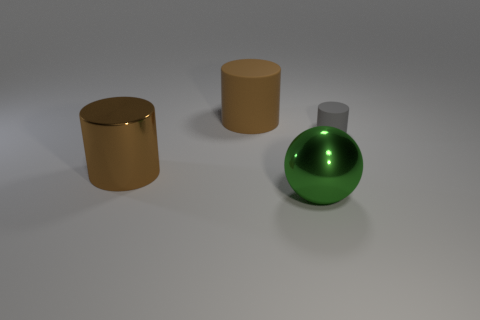There is a cylinder that is both behind the shiny cylinder and to the left of the tiny object; what color is it?
Make the answer very short. Brown. What is the size of the matte cylinder on the left side of the green object?
Give a very brief answer. Large. How many yellow blocks are made of the same material as the small object?
Keep it short and to the point. 0. What shape is the big object that is the same color as the metallic cylinder?
Provide a succinct answer. Cylinder. There is a large brown rubber object left of the tiny rubber thing; is it the same shape as the small gray rubber object?
Your answer should be compact. Yes. What is the color of the other cylinder that is made of the same material as the gray cylinder?
Give a very brief answer. Brown. Are there any gray rubber objects that are in front of the big cylinder that is behind the brown cylinder that is in front of the gray matte cylinder?
Keep it short and to the point. Yes. The green shiny thing has what shape?
Offer a very short reply. Sphere. Are there fewer green balls on the right side of the big matte object than big purple rubber things?
Make the answer very short. No. Are there any large brown things that have the same shape as the gray matte object?
Your answer should be very brief. Yes. 